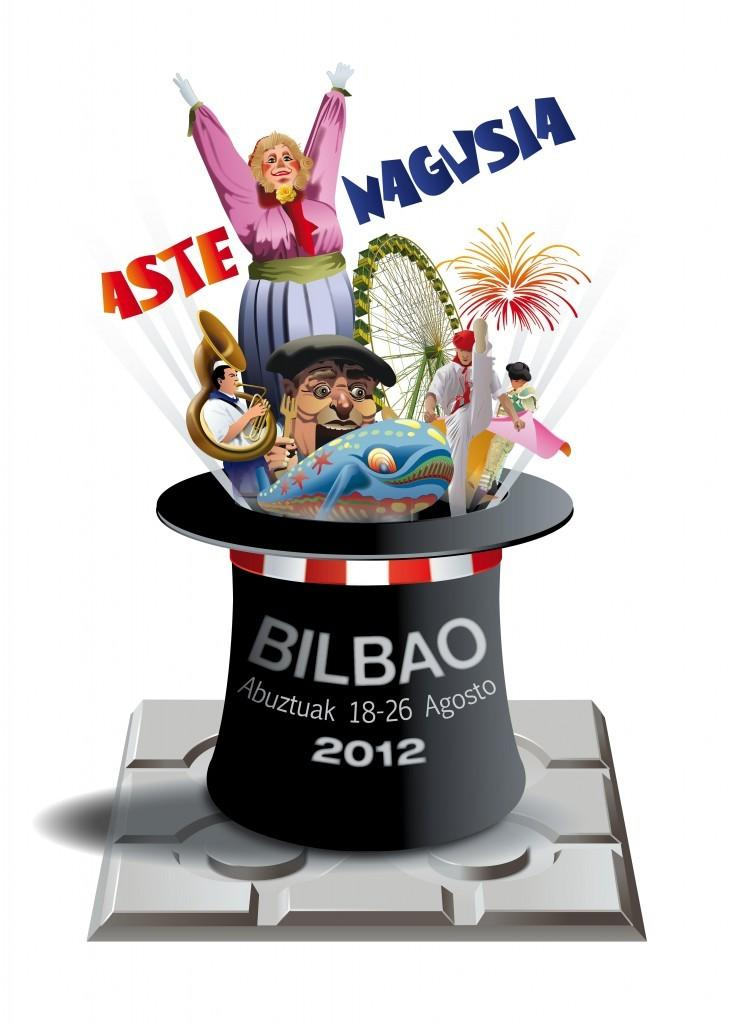What type of image is being described? The image appears to be animated. What is on the hat that is visible in the image? There is a hat with letters on it. Who or what can be seen in the image? There are people and an animal in the image. What large object is present in the image? There is a giant wheel in the image. What can be read or identified in the image? There are letters visible in the image. What reason is given for the approval of the stick in the image? There is no stick present in the image, and therefore no reason for approval can be determined. 